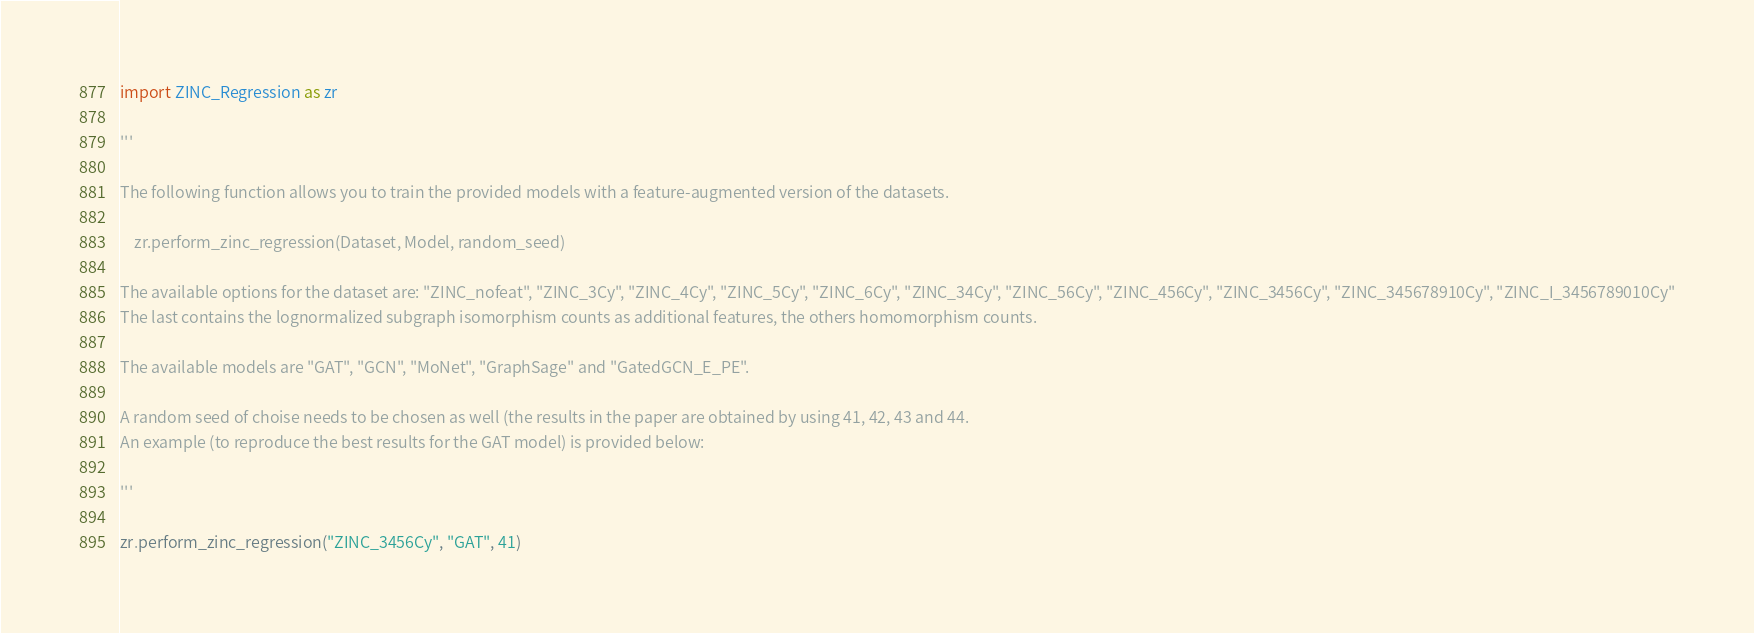Convert code to text. <code><loc_0><loc_0><loc_500><loc_500><_Python_>import ZINC_Regression as zr

'''

The following function allows you to train the provided models with a feature-augmented version of the datasets. 

    zr.perform_zinc_regression(Dataset, Model, random_seed)

The available options for the dataset are: "ZINC_nofeat", "ZINC_3Cy", "ZINC_4Cy", "ZINC_5Cy", "ZINC_6Cy", "ZINC_34Cy", "ZINC_56Cy", "ZINC_456Cy", "ZINC_3456Cy", "ZINC_345678910Cy", "ZINC_I_3456789010Cy"
The last contains the lognormalized subgraph isomorphism counts as additional features, the others homomorphism counts.

The available models are "GAT", "GCN", "MoNet", "GraphSage" and "GatedGCN_E_PE".

A random seed of choise needs to be chosen as well (the results in the paper are obtained by using 41, 42, 43 and 44.
An example (to reproduce the best results for the GAT model) is provided below:

'''

zr.perform_zinc_regression("ZINC_3456Cy", "GAT", 41)
</code> 